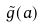<formula> <loc_0><loc_0><loc_500><loc_500>\tilde { g } ( a )</formula> 